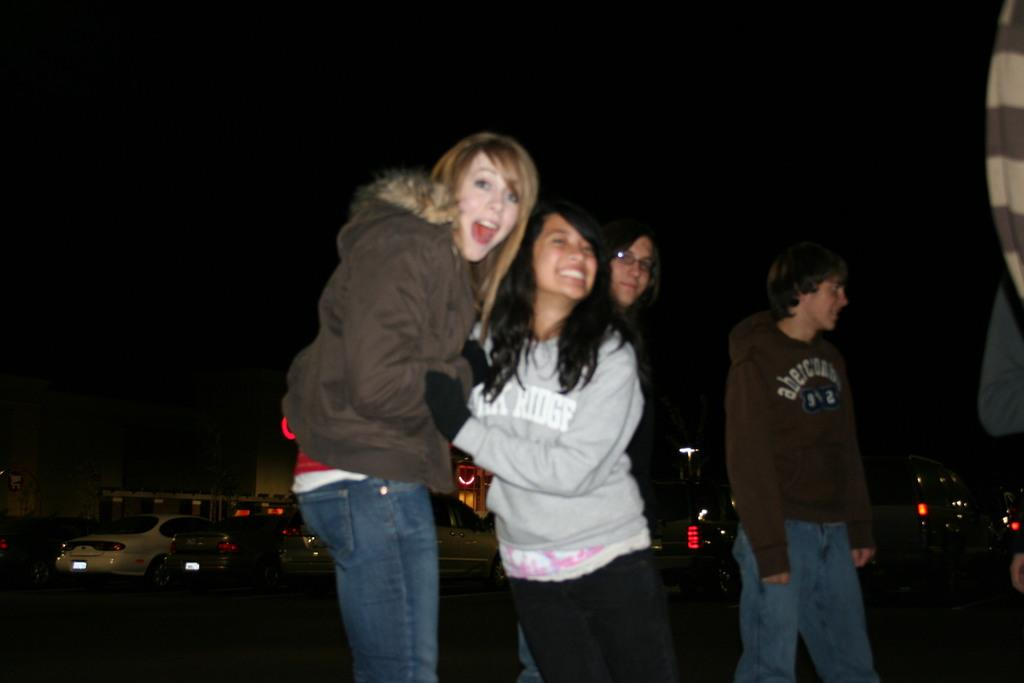How many people are in the image? There are four people in the image. What are two of the people doing in the image? Two of the people are posing for the picture. What can be seen in the background of the image? There are vehicles visible in the background. Can you describe the lighting in the image? The background of the image is dark. What type of icicle can be seen hanging from the roof in the image? There is no icicle present in the image, as it is not snowing or cold enough for icicles to form. --- Facts: 1. There is a person holding a book in the image. 2. The book has a blue cover. 3. The person is sitting on a chair. 4. There is a table next to the chair. 5. The table has a lamp on it. Absurd Topics: parrot, volcano, ocean Conversation: What is the person in the image holding? The person is holding a book in the image. What color is the book's cover? The book has a blue cover. Where is the person sitting in the image? The person is sitting on a chair. What is located next to the chair? There is a table next to the chair. What can be seen on the table? The table has a lamp on it. Reasoning: Let's think step by step in order to produce the conversation. We start by identifying the main subject in the image, which is the person holding a book. Then, we describe the book's cover color, which is blue. Next, we mention the person's seating arrangement, noting that they are sitting on a chair. We then describe the table next to the chair and the lamp on it. Each question is designed to elicit a specific detail about the image that is known from the provided facts. Absurd Question/Answer: Can you see a parrot perched on the lamp in the image? There is no parrot present in the image; only a person holding a book, a chair, a table, and a lamp are visible. 